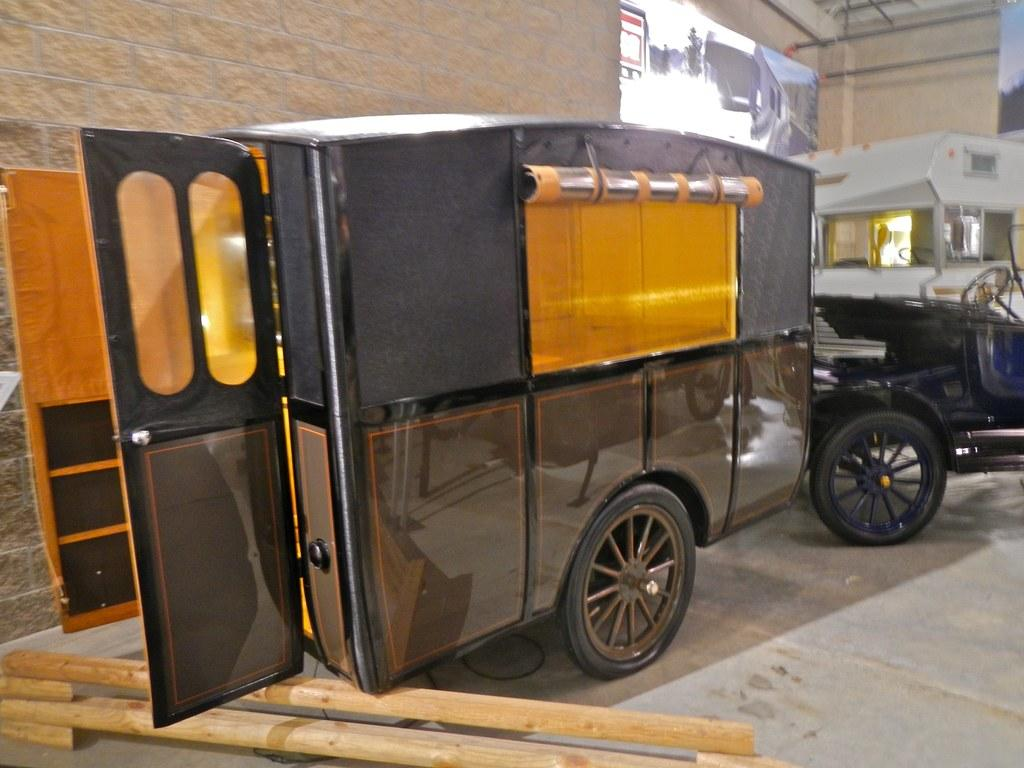What type of objects can be seen in the image? There are vehicles in the image. What material is on the floor in the image? There is wood on the floor in the image. What is visible in the background of the image? There is a wall visible in the image. Can you describe any other objects present in the image? There are other objects present in the image, but their specific details are not mentioned in the provided facts. What type of treatment or care is being provided to the vehicles in the image? There is no indication in the image that any treatment or care is being provided to the vehicles. 